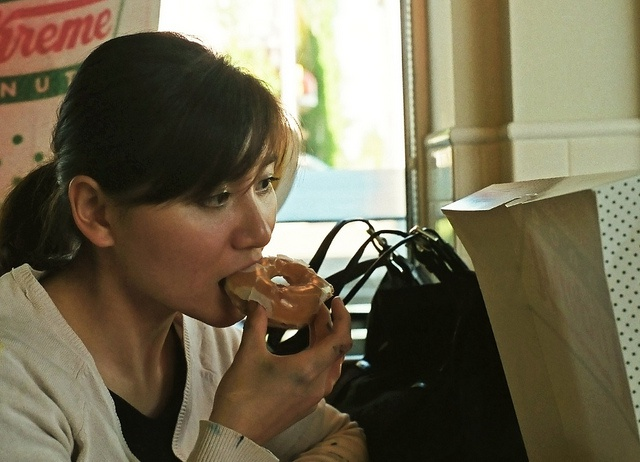Describe the objects in this image and their specific colors. I can see people in black, maroon, and gray tones, handbag in black, ivory, darkgreen, and gray tones, and donut in black, maroon, and brown tones in this image. 